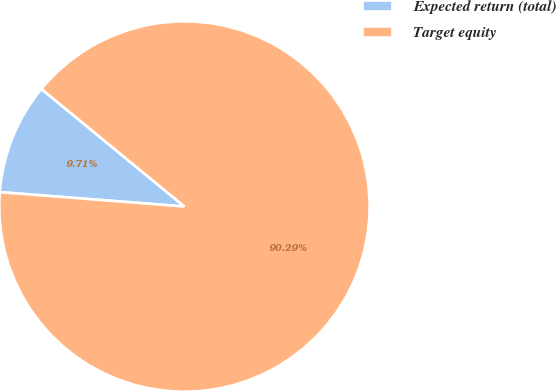Convert chart. <chart><loc_0><loc_0><loc_500><loc_500><pie_chart><fcel>Expected return (total)<fcel>Target equity<nl><fcel>9.71%<fcel>90.29%<nl></chart> 